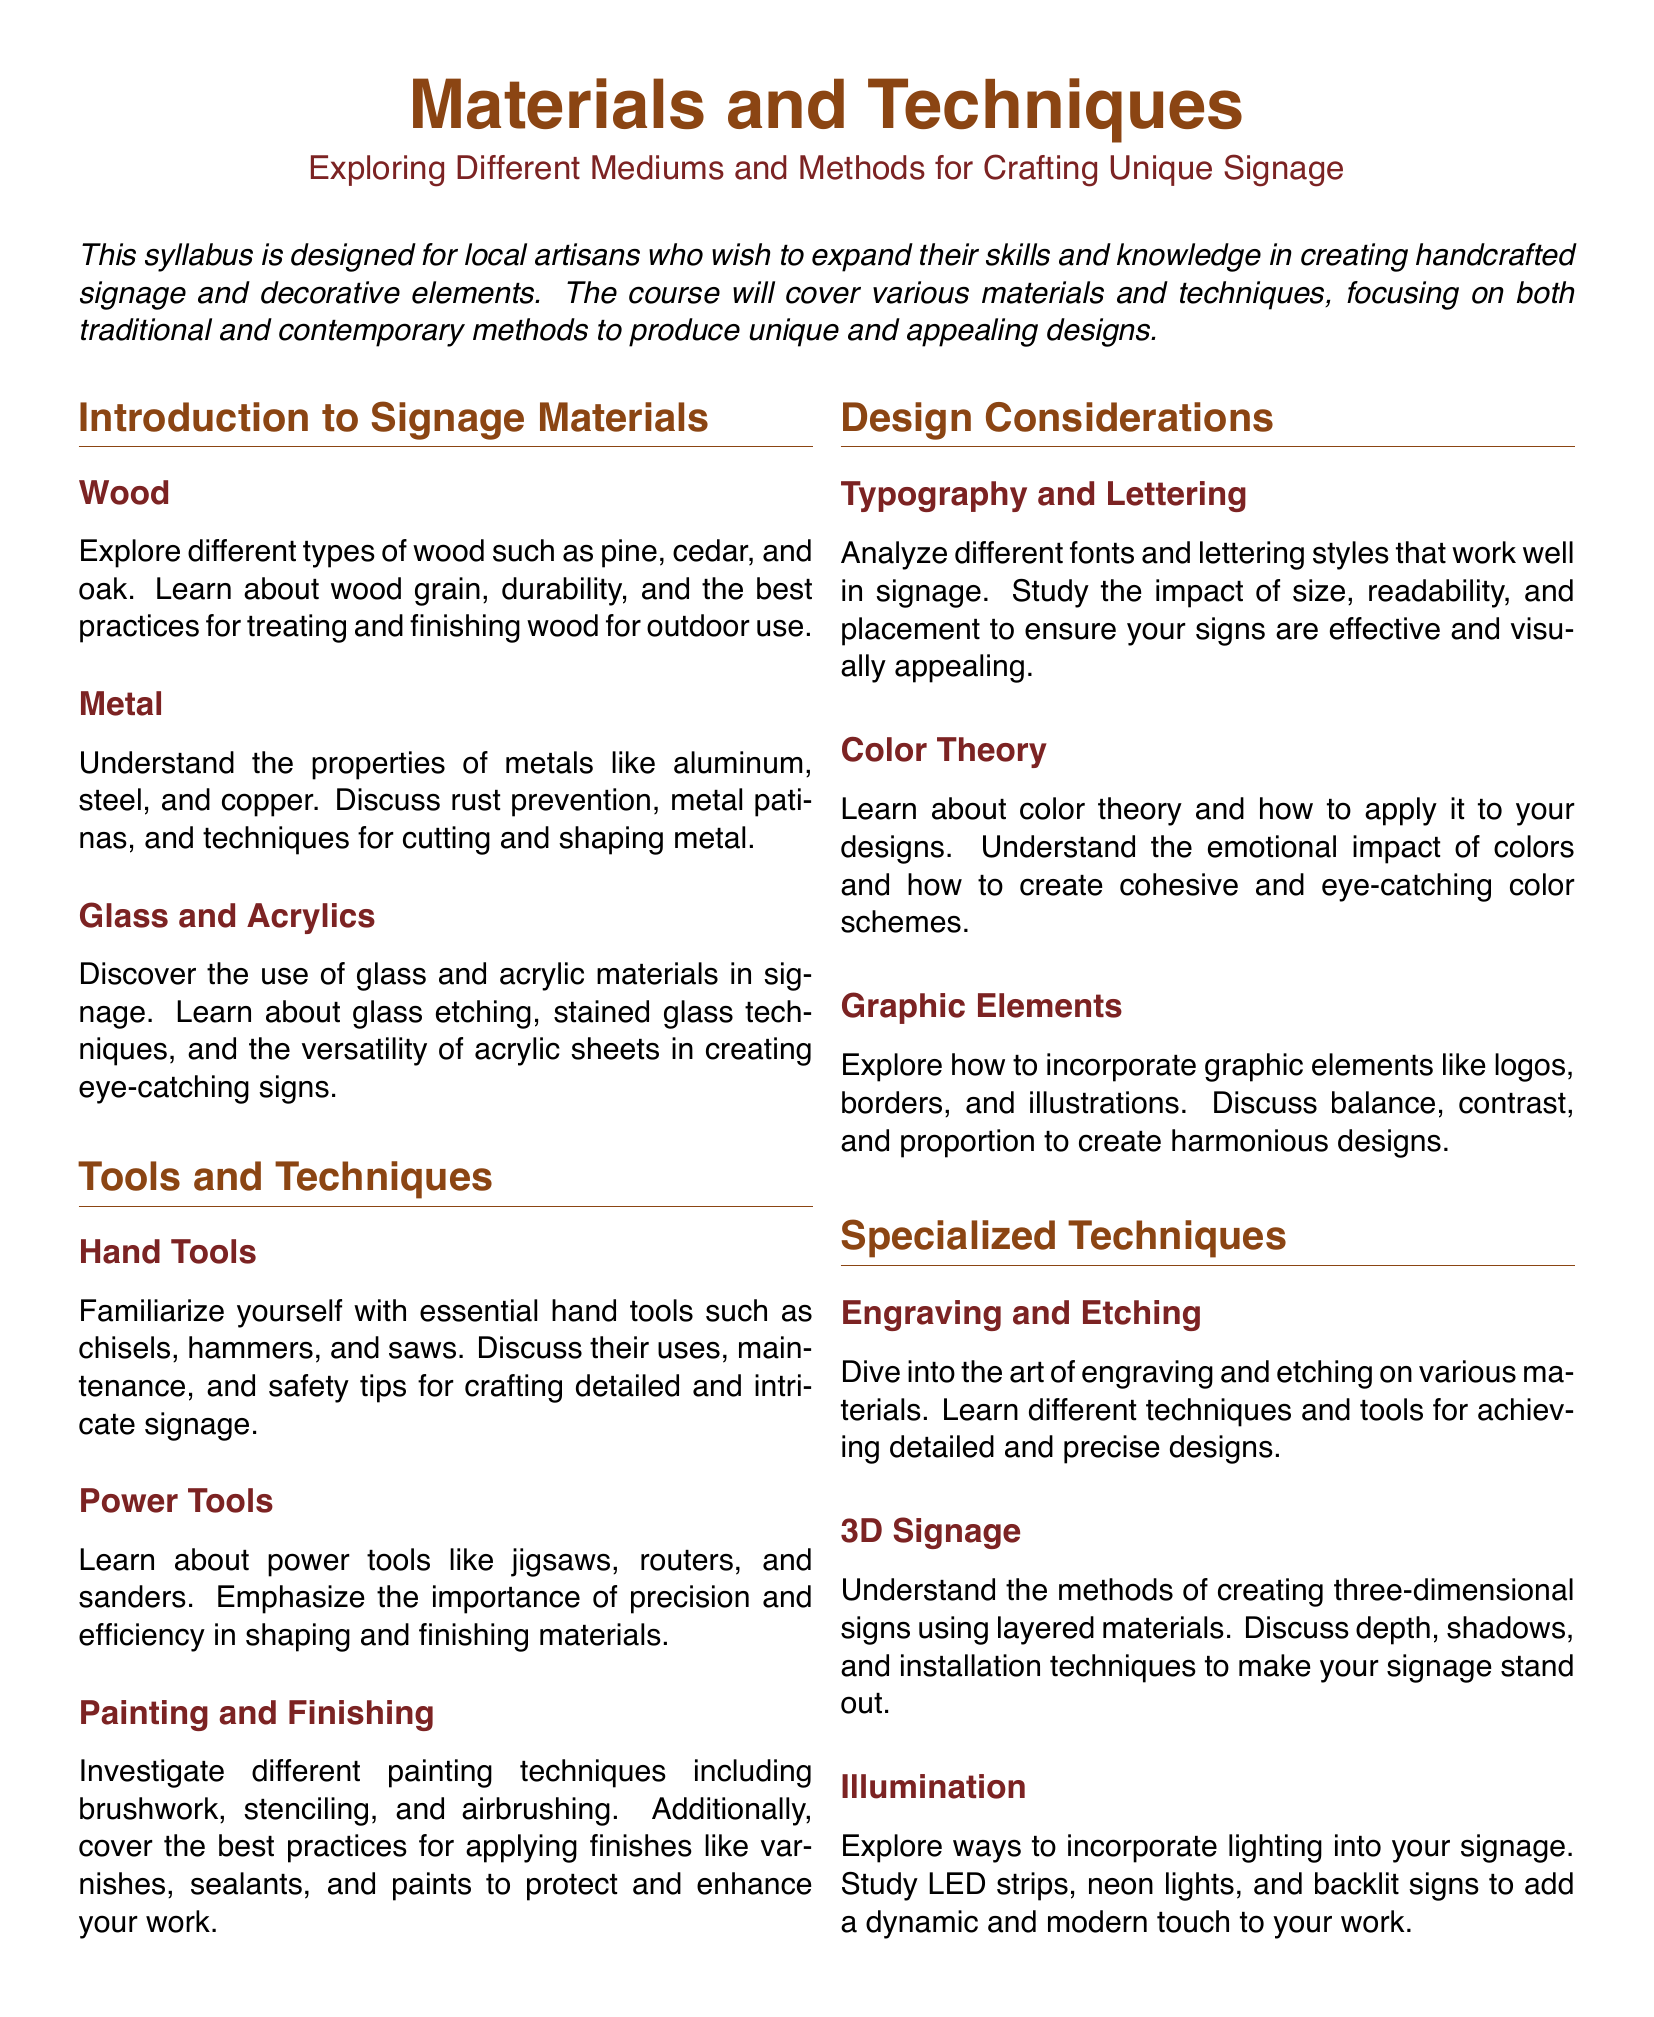What are the types of wood mentioned? The document lists different types of wood such as pine, cedar, and oak.
Answer: pine, cedar, oak What metals are discussed in the syllabus? The syllabus includes metals like aluminum, steel, and copper in its discussions.
Answer: aluminum, steel, copper What is covered under painting techniques? The document investigates different painting techniques including brushwork, stenciling, and airbrushing.
Answer: brushwork, stenciling, airbrushing How many specialized techniques are listed? There are three specialized techniques listed in the syllabus: engraving and etching, 3D signage, and illumination.
Answer: three What color concept is studied? The syllabus includes a section on color theory in relation to design.
Answer: color theory What is emphasized in the tools section regarding power tools? The importance of precision and efficiency in shaping and finishing materials is emphasized.
Answer: precision and efficiency Which section would cover the emotional impact of colors? The emotional impact of colors is discussed under color theory in the design considerations section.
Answer: color theory What type of design elements are explored besides typography? The syllabus discusses graphic elements, which include logos, borders, and illustrations.
Answer: graphic elements 